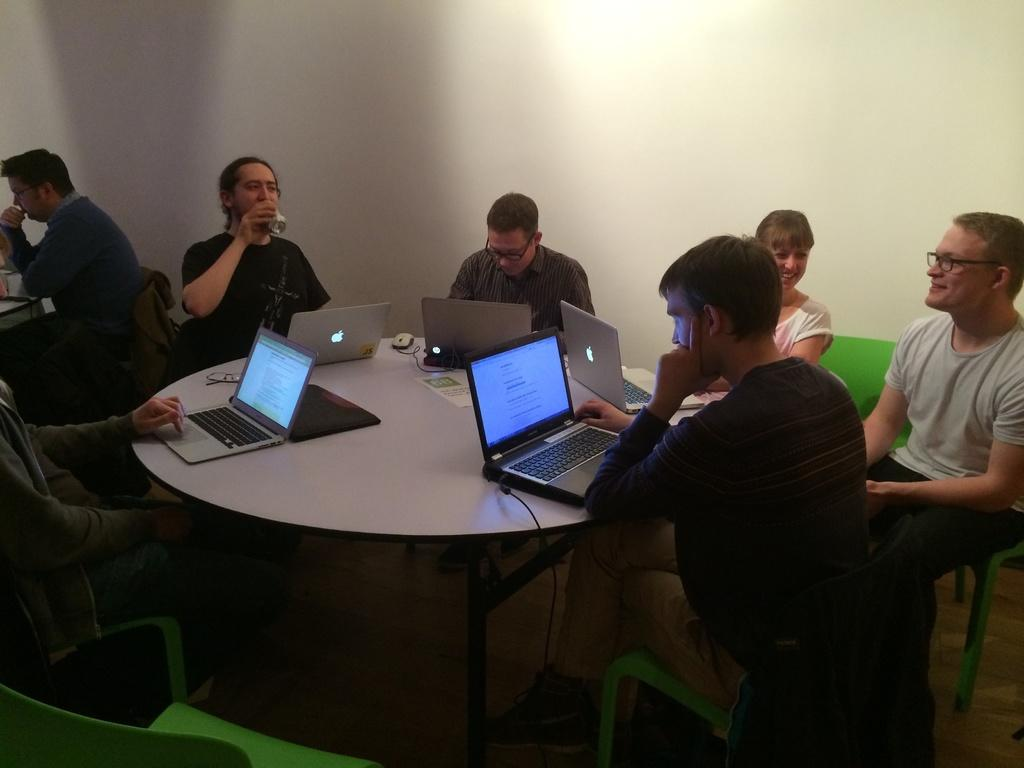What are the people in the image doing? The people in the image are sitting on chairs. What is in front of the people? There is a table in front of the people. What can be seen on the table? Laptops are present on the table. What can be seen in the background of the image? There is a wall visible in the background of the image. Are there any children playing with a sign in the image? There is no mention of children or a sign in the image; it only features people sitting on chairs with laptops on a table and a wall in the background. 